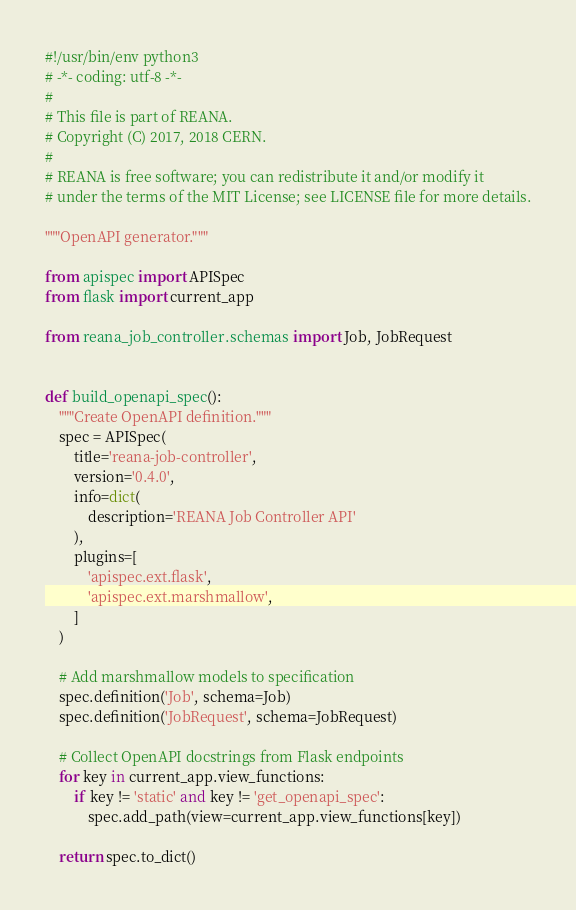<code> <loc_0><loc_0><loc_500><loc_500><_Python_>#!/usr/bin/env python3
# -*- coding: utf-8 -*-
#
# This file is part of REANA.
# Copyright (C) 2017, 2018 CERN.
#
# REANA is free software; you can redistribute it and/or modify it
# under the terms of the MIT License; see LICENSE file for more details.

"""OpenAPI generator."""

from apispec import APISpec
from flask import current_app

from reana_job_controller.schemas import Job, JobRequest


def build_openapi_spec():
    """Create OpenAPI definition."""
    spec = APISpec(
        title='reana-job-controller',
        version='0.4.0',
        info=dict(
            description='REANA Job Controller API'
        ),
        plugins=[
            'apispec.ext.flask',
            'apispec.ext.marshmallow',
        ]
    )

    # Add marshmallow models to specification
    spec.definition('Job', schema=Job)
    spec.definition('JobRequest', schema=JobRequest)

    # Collect OpenAPI docstrings from Flask endpoints
    for key in current_app.view_functions:
        if key != 'static' and key != 'get_openapi_spec':
            spec.add_path(view=current_app.view_functions[key])

    return spec.to_dict()
</code> 